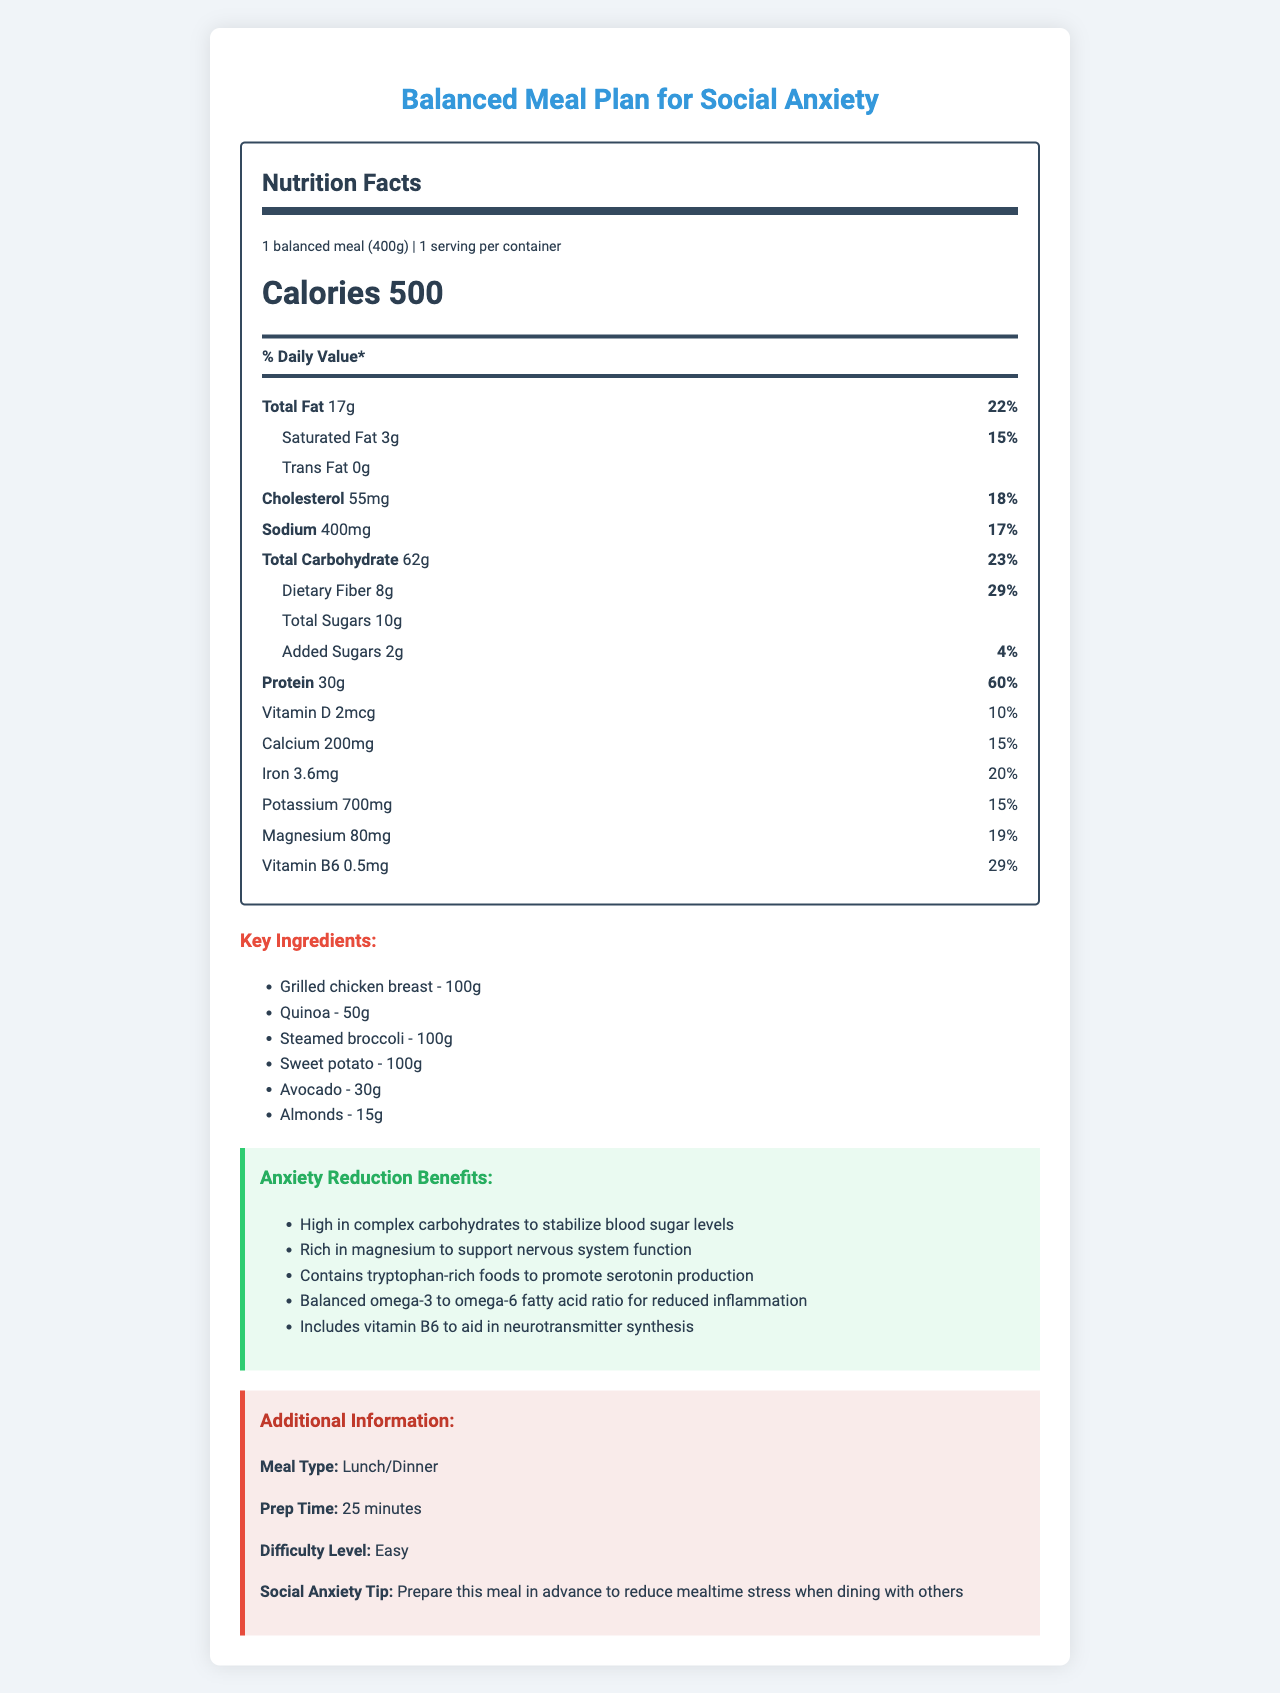what is the serving size of the balanced meal? The serving size is clearly mentioned as "1 balanced meal (400g)" in the document under the "servingSize" section.
Answer: 1 balanced meal (400g) how many calories are there per serving? The document lists the calories per serving as 500.
Answer: 500 what is the percentage daily value of dietary fiber in this meal? The section for dietary fiber states that it amounts to 8g and has a daily value percentage of 29%.
Answer: 29% how much protein does this meal provide? The document mentions that the protein content is 30g with a daily value of 60%.
Answer: 30g what are the key ingredients of the meal? The key ingredients are listed under the "Key Ingredients" section.
Answer: Grilled chicken breast, Quinoa, Steamed broccoli, Sweet potato, Avocado, Almonds what type of meal is this intended for? A. Breakfast B. Lunch/Dinner C. Snack D. Dessert The document indicates the "mealType" as "Lunch/Dinner".
Answer: B what is the preparation time for this meal? A. 15 minutes B. 25 minutes C. 35 minutes D. 45 minutes The "Prep Time" is listed as 25 minutes in the "Additional Information" section.
Answer: B does this meal contain trans fat? The document specifies that the amount of trans fat is 0g, implying that it contains no trans fat.
Answer: No is it possible to determine the exact recipe to prepare this meal? The document lists the key ingredients and their amounts but does not provide specific cooking steps or a recipe.
Answer: Not enough information summarize the main idea of the document The document provides comprehensive nutritional information, key ingredients, and anxiety reduction benefits, along with practical preparation advice for a balanced meal tailored to social anxiety sufferers.
Answer: The document presents a detailed Nutrition Facts Label for a balanced meal designed to help social anxiety sufferers. It includes information about macronutrients, micronutrients, key ingredients, and specific benefits for reducing anxiety. Additionally, it provides prep time, meal type, and a social anxiety tip. 